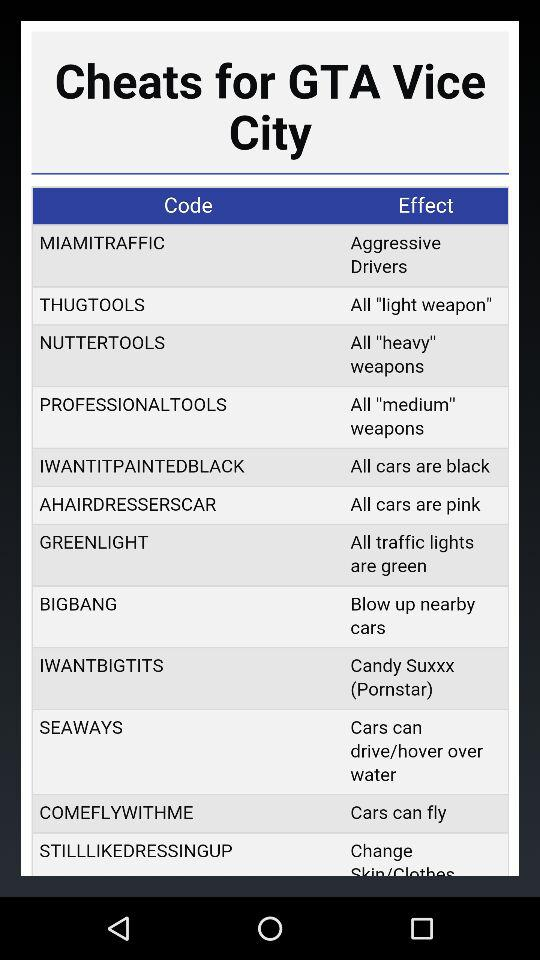How many cheats are for weapons?
Answer the question using a single word or phrase. 3 